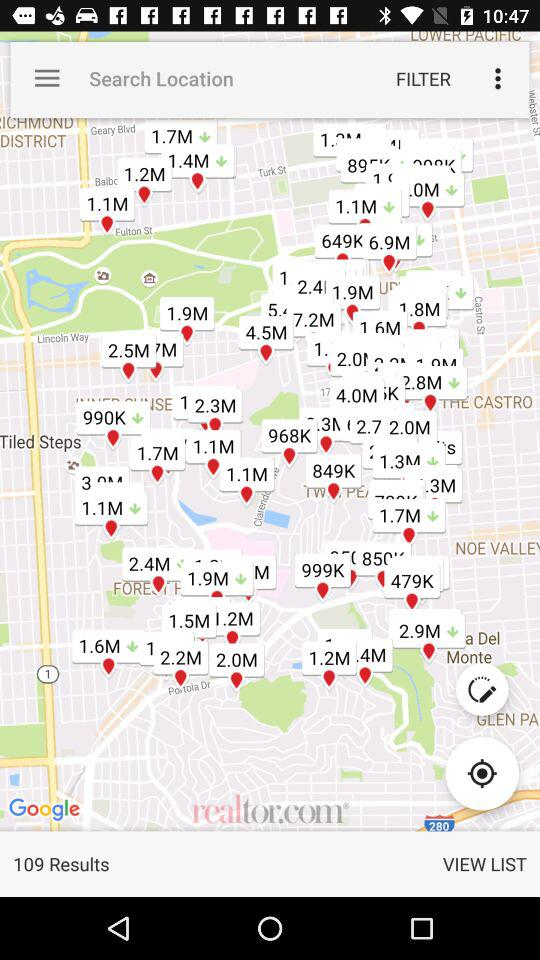What is the number of results? The number of results is 109. 